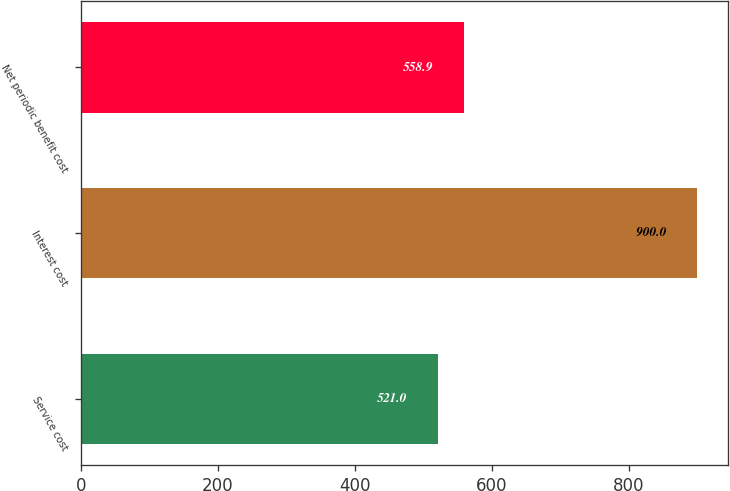<chart> <loc_0><loc_0><loc_500><loc_500><bar_chart><fcel>Service cost<fcel>Interest cost<fcel>Net periodic benefit cost<nl><fcel>521<fcel>900<fcel>558.9<nl></chart> 